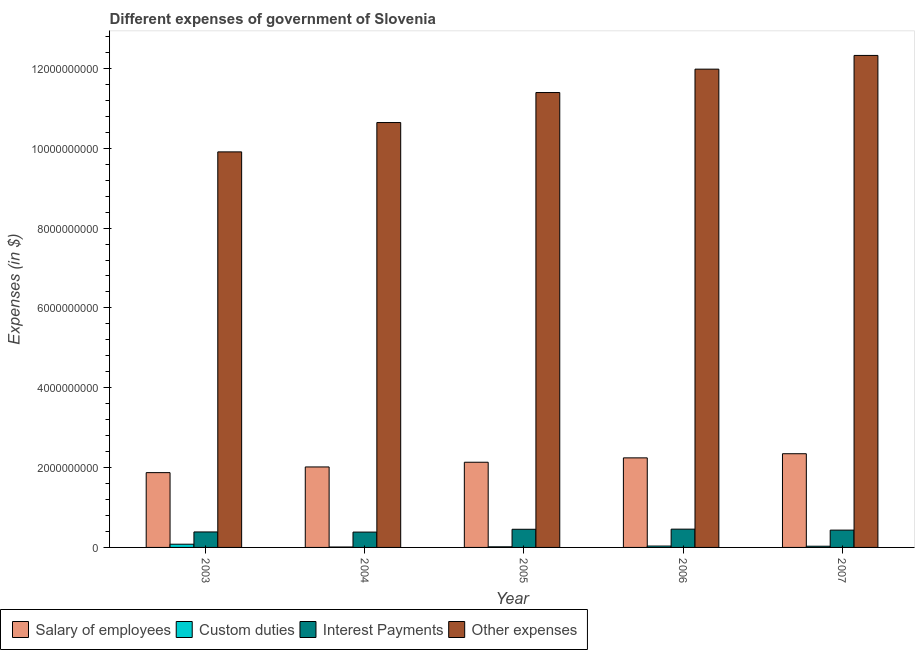How many different coloured bars are there?
Give a very brief answer. 4. Are the number of bars on each tick of the X-axis equal?
Give a very brief answer. Yes. How many bars are there on the 1st tick from the right?
Ensure brevity in your answer.  4. In how many cases, is the number of bars for a given year not equal to the number of legend labels?
Make the answer very short. 0. What is the amount spent on interest payments in 2004?
Your answer should be very brief. 3.84e+08. Across all years, what is the maximum amount spent on other expenses?
Ensure brevity in your answer.  1.23e+1. Across all years, what is the minimum amount spent on custom duties?
Keep it short and to the point. 1.07e+07. In which year was the amount spent on salary of employees maximum?
Give a very brief answer. 2007. What is the total amount spent on other expenses in the graph?
Make the answer very short. 5.63e+1. What is the difference between the amount spent on other expenses in 2004 and that in 2006?
Make the answer very short. -1.34e+09. What is the difference between the amount spent on other expenses in 2003 and the amount spent on custom duties in 2006?
Your answer should be very brief. -2.07e+09. What is the average amount spent on salary of employees per year?
Your answer should be very brief. 2.12e+09. In how many years, is the amount spent on interest payments greater than 2800000000 $?
Offer a very short reply. 0. What is the ratio of the amount spent on other expenses in 2003 to that in 2007?
Your answer should be very brief. 0.8. What is the difference between the highest and the second highest amount spent on custom duties?
Offer a very short reply. 4.62e+07. What is the difference between the highest and the lowest amount spent on salary of employees?
Give a very brief answer. 4.74e+08. In how many years, is the amount spent on custom duties greater than the average amount spent on custom duties taken over all years?
Keep it short and to the point. 2. What does the 4th bar from the left in 2004 represents?
Provide a succinct answer. Other expenses. What does the 2nd bar from the right in 2005 represents?
Your answer should be compact. Interest Payments. Is it the case that in every year, the sum of the amount spent on salary of employees and amount spent on custom duties is greater than the amount spent on interest payments?
Give a very brief answer. Yes. Are all the bars in the graph horizontal?
Your answer should be very brief. No. Are the values on the major ticks of Y-axis written in scientific E-notation?
Your response must be concise. No. Does the graph contain any zero values?
Your answer should be compact. No. Does the graph contain grids?
Provide a short and direct response. No. Where does the legend appear in the graph?
Your answer should be compact. Bottom left. How many legend labels are there?
Provide a short and direct response. 4. How are the legend labels stacked?
Your answer should be very brief. Horizontal. What is the title of the graph?
Keep it short and to the point. Different expenses of government of Slovenia. What is the label or title of the X-axis?
Provide a succinct answer. Year. What is the label or title of the Y-axis?
Your response must be concise. Expenses (in $). What is the Expenses (in $) in Salary of employees in 2003?
Give a very brief answer. 1.87e+09. What is the Expenses (in $) in Custom duties in 2003?
Offer a terse response. 8.07e+07. What is the Expenses (in $) of Interest Payments in 2003?
Your answer should be very brief. 3.88e+08. What is the Expenses (in $) in Other expenses in 2003?
Your answer should be very brief. 9.91e+09. What is the Expenses (in $) of Salary of employees in 2004?
Give a very brief answer. 2.02e+09. What is the Expenses (in $) in Custom duties in 2004?
Your response must be concise. 1.07e+07. What is the Expenses (in $) of Interest Payments in 2004?
Offer a very short reply. 3.84e+08. What is the Expenses (in $) in Other expenses in 2004?
Offer a terse response. 1.06e+1. What is the Expenses (in $) of Salary of employees in 2005?
Ensure brevity in your answer.  2.13e+09. What is the Expenses (in $) of Custom duties in 2005?
Make the answer very short. 1.52e+07. What is the Expenses (in $) of Interest Payments in 2005?
Your response must be concise. 4.55e+08. What is the Expenses (in $) of Other expenses in 2005?
Your answer should be compact. 1.14e+1. What is the Expenses (in $) in Salary of employees in 2006?
Keep it short and to the point. 2.24e+09. What is the Expenses (in $) of Custom duties in 2006?
Ensure brevity in your answer.  3.45e+07. What is the Expenses (in $) of Interest Payments in 2006?
Offer a very short reply. 4.58e+08. What is the Expenses (in $) in Other expenses in 2006?
Make the answer very short. 1.20e+1. What is the Expenses (in $) in Salary of employees in 2007?
Provide a short and direct response. 2.35e+09. What is the Expenses (in $) of Custom duties in 2007?
Make the answer very short. 3.00e+07. What is the Expenses (in $) of Interest Payments in 2007?
Provide a short and direct response. 4.34e+08. What is the Expenses (in $) of Other expenses in 2007?
Ensure brevity in your answer.  1.23e+1. Across all years, what is the maximum Expenses (in $) of Salary of employees?
Offer a very short reply. 2.35e+09. Across all years, what is the maximum Expenses (in $) in Custom duties?
Offer a very short reply. 8.07e+07. Across all years, what is the maximum Expenses (in $) of Interest Payments?
Keep it short and to the point. 4.58e+08. Across all years, what is the maximum Expenses (in $) in Other expenses?
Make the answer very short. 1.23e+1. Across all years, what is the minimum Expenses (in $) of Salary of employees?
Provide a succinct answer. 1.87e+09. Across all years, what is the minimum Expenses (in $) in Custom duties?
Offer a very short reply. 1.07e+07. Across all years, what is the minimum Expenses (in $) of Interest Payments?
Ensure brevity in your answer.  3.84e+08. Across all years, what is the minimum Expenses (in $) of Other expenses?
Offer a very short reply. 9.91e+09. What is the total Expenses (in $) of Salary of employees in the graph?
Make the answer very short. 1.06e+1. What is the total Expenses (in $) in Custom duties in the graph?
Offer a very short reply. 1.71e+08. What is the total Expenses (in $) of Interest Payments in the graph?
Make the answer very short. 2.12e+09. What is the total Expenses (in $) of Other expenses in the graph?
Your answer should be compact. 5.63e+1. What is the difference between the Expenses (in $) in Salary of employees in 2003 and that in 2004?
Provide a succinct answer. -1.42e+08. What is the difference between the Expenses (in $) of Custom duties in 2003 and that in 2004?
Provide a short and direct response. 7.00e+07. What is the difference between the Expenses (in $) of Interest Payments in 2003 and that in 2004?
Your answer should be very brief. 3.56e+06. What is the difference between the Expenses (in $) of Other expenses in 2003 and that in 2004?
Provide a succinct answer. -7.35e+08. What is the difference between the Expenses (in $) of Salary of employees in 2003 and that in 2005?
Make the answer very short. -2.60e+08. What is the difference between the Expenses (in $) of Custom duties in 2003 and that in 2005?
Provide a short and direct response. 6.55e+07. What is the difference between the Expenses (in $) in Interest Payments in 2003 and that in 2005?
Ensure brevity in your answer.  -6.71e+07. What is the difference between the Expenses (in $) of Other expenses in 2003 and that in 2005?
Your answer should be very brief. -1.49e+09. What is the difference between the Expenses (in $) in Salary of employees in 2003 and that in 2006?
Give a very brief answer. -3.70e+08. What is the difference between the Expenses (in $) in Custom duties in 2003 and that in 2006?
Your answer should be compact. 4.62e+07. What is the difference between the Expenses (in $) in Interest Payments in 2003 and that in 2006?
Provide a succinct answer. -7.00e+07. What is the difference between the Expenses (in $) in Other expenses in 2003 and that in 2006?
Ensure brevity in your answer.  -2.07e+09. What is the difference between the Expenses (in $) of Salary of employees in 2003 and that in 2007?
Provide a succinct answer. -4.74e+08. What is the difference between the Expenses (in $) in Custom duties in 2003 and that in 2007?
Your response must be concise. 5.07e+07. What is the difference between the Expenses (in $) of Interest Payments in 2003 and that in 2007?
Your response must be concise. -4.60e+07. What is the difference between the Expenses (in $) of Other expenses in 2003 and that in 2007?
Provide a short and direct response. -2.42e+09. What is the difference between the Expenses (in $) in Salary of employees in 2004 and that in 2005?
Offer a very short reply. -1.18e+08. What is the difference between the Expenses (in $) of Custom duties in 2004 and that in 2005?
Your response must be concise. -4.50e+06. What is the difference between the Expenses (in $) of Interest Payments in 2004 and that in 2005?
Ensure brevity in your answer.  -7.07e+07. What is the difference between the Expenses (in $) in Other expenses in 2004 and that in 2005?
Offer a very short reply. -7.52e+08. What is the difference between the Expenses (in $) in Salary of employees in 2004 and that in 2006?
Your response must be concise. -2.28e+08. What is the difference between the Expenses (in $) of Custom duties in 2004 and that in 2006?
Ensure brevity in your answer.  -2.39e+07. What is the difference between the Expenses (in $) of Interest Payments in 2004 and that in 2006?
Your answer should be very brief. -7.36e+07. What is the difference between the Expenses (in $) of Other expenses in 2004 and that in 2006?
Give a very brief answer. -1.34e+09. What is the difference between the Expenses (in $) of Salary of employees in 2004 and that in 2007?
Keep it short and to the point. -3.31e+08. What is the difference between the Expenses (in $) in Custom duties in 2004 and that in 2007?
Offer a terse response. -1.94e+07. What is the difference between the Expenses (in $) in Interest Payments in 2004 and that in 2007?
Keep it short and to the point. -4.95e+07. What is the difference between the Expenses (in $) in Other expenses in 2004 and that in 2007?
Your answer should be compact. -1.68e+09. What is the difference between the Expenses (in $) in Salary of employees in 2005 and that in 2006?
Your response must be concise. -1.10e+08. What is the difference between the Expenses (in $) of Custom duties in 2005 and that in 2006?
Give a very brief answer. -1.94e+07. What is the difference between the Expenses (in $) of Interest Payments in 2005 and that in 2006?
Provide a short and direct response. -2.91e+06. What is the difference between the Expenses (in $) in Other expenses in 2005 and that in 2006?
Offer a very short reply. -5.86e+08. What is the difference between the Expenses (in $) of Salary of employees in 2005 and that in 2007?
Offer a very short reply. -2.14e+08. What is the difference between the Expenses (in $) in Custom duties in 2005 and that in 2007?
Offer a very short reply. -1.49e+07. What is the difference between the Expenses (in $) of Interest Payments in 2005 and that in 2007?
Keep it short and to the point. 2.12e+07. What is the difference between the Expenses (in $) of Other expenses in 2005 and that in 2007?
Keep it short and to the point. -9.30e+08. What is the difference between the Expenses (in $) in Salary of employees in 2006 and that in 2007?
Offer a terse response. -1.04e+08. What is the difference between the Expenses (in $) of Custom duties in 2006 and that in 2007?
Provide a succinct answer. 4.51e+06. What is the difference between the Expenses (in $) of Interest Payments in 2006 and that in 2007?
Make the answer very short. 2.41e+07. What is the difference between the Expenses (in $) of Other expenses in 2006 and that in 2007?
Provide a succinct answer. -3.44e+08. What is the difference between the Expenses (in $) of Salary of employees in 2003 and the Expenses (in $) of Custom duties in 2004?
Ensure brevity in your answer.  1.86e+09. What is the difference between the Expenses (in $) in Salary of employees in 2003 and the Expenses (in $) in Interest Payments in 2004?
Offer a terse response. 1.49e+09. What is the difference between the Expenses (in $) of Salary of employees in 2003 and the Expenses (in $) of Other expenses in 2004?
Keep it short and to the point. -8.77e+09. What is the difference between the Expenses (in $) in Custom duties in 2003 and the Expenses (in $) in Interest Payments in 2004?
Ensure brevity in your answer.  -3.03e+08. What is the difference between the Expenses (in $) in Custom duties in 2003 and the Expenses (in $) in Other expenses in 2004?
Offer a terse response. -1.06e+1. What is the difference between the Expenses (in $) of Interest Payments in 2003 and the Expenses (in $) of Other expenses in 2004?
Your answer should be very brief. -1.03e+1. What is the difference between the Expenses (in $) in Salary of employees in 2003 and the Expenses (in $) in Custom duties in 2005?
Provide a short and direct response. 1.86e+09. What is the difference between the Expenses (in $) of Salary of employees in 2003 and the Expenses (in $) of Interest Payments in 2005?
Offer a very short reply. 1.42e+09. What is the difference between the Expenses (in $) of Salary of employees in 2003 and the Expenses (in $) of Other expenses in 2005?
Offer a terse response. -9.52e+09. What is the difference between the Expenses (in $) of Custom duties in 2003 and the Expenses (in $) of Interest Payments in 2005?
Provide a succinct answer. -3.74e+08. What is the difference between the Expenses (in $) in Custom duties in 2003 and the Expenses (in $) in Other expenses in 2005?
Your answer should be compact. -1.13e+1. What is the difference between the Expenses (in $) of Interest Payments in 2003 and the Expenses (in $) of Other expenses in 2005?
Keep it short and to the point. -1.10e+1. What is the difference between the Expenses (in $) of Salary of employees in 2003 and the Expenses (in $) of Custom duties in 2006?
Your answer should be very brief. 1.84e+09. What is the difference between the Expenses (in $) in Salary of employees in 2003 and the Expenses (in $) in Interest Payments in 2006?
Your answer should be compact. 1.42e+09. What is the difference between the Expenses (in $) of Salary of employees in 2003 and the Expenses (in $) of Other expenses in 2006?
Your response must be concise. -1.01e+1. What is the difference between the Expenses (in $) in Custom duties in 2003 and the Expenses (in $) in Interest Payments in 2006?
Give a very brief answer. -3.77e+08. What is the difference between the Expenses (in $) of Custom duties in 2003 and the Expenses (in $) of Other expenses in 2006?
Ensure brevity in your answer.  -1.19e+1. What is the difference between the Expenses (in $) of Interest Payments in 2003 and the Expenses (in $) of Other expenses in 2006?
Make the answer very short. -1.16e+1. What is the difference between the Expenses (in $) of Salary of employees in 2003 and the Expenses (in $) of Custom duties in 2007?
Ensure brevity in your answer.  1.84e+09. What is the difference between the Expenses (in $) of Salary of employees in 2003 and the Expenses (in $) of Interest Payments in 2007?
Your response must be concise. 1.44e+09. What is the difference between the Expenses (in $) in Salary of employees in 2003 and the Expenses (in $) in Other expenses in 2007?
Your answer should be compact. -1.05e+1. What is the difference between the Expenses (in $) in Custom duties in 2003 and the Expenses (in $) in Interest Payments in 2007?
Provide a succinct answer. -3.53e+08. What is the difference between the Expenses (in $) in Custom duties in 2003 and the Expenses (in $) in Other expenses in 2007?
Ensure brevity in your answer.  -1.22e+1. What is the difference between the Expenses (in $) of Interest Payments in 2003 and the Expenses (in $) of Other expenses in 2007?
Offer a very short reply. -1.19e+1. What is the difference between the Expenses (in $) of Salary of employees in 2004 and the Expenses (in $) of Custom duties in 2005?
Provide a succinct answer. 2.00e+09. What is the difference between the Expenses (in $) in Salary of employees in 2004 and the Expenses (in $) in Interest Payments in 2005?
Provide a short and direct response. 1.56e+09. What is the difference between the Expenses (in $) in Salary of employees in 2004 and the Expenses (in $) in Other expenses in 2005?
Ensure brevity in your answer.  -9.38e+09. What is the difference between the Expenses (in $) in Custom duties in 2004 and the Expenses (in $) in Interest Payments in 2005?
Ensure brevity in your answer.  -4.44e+08. What is the difference between the Expenses (in $) in Custom duties in 2004 and the Expenses (in $) in Other expenses in 2005?
Offer a very short reply. -1.14e+1. What is the difference between the Expenses (in $) of Interest Payments in 2004 and the Expenses (in $) of Other expenses in 2005?
Your answer should be compact. -1.10e+1. What is the difference between the Expenses (in $) of Salary of employees in 2004 and the Expenses (in $) of Custom duties in 2006?
Keep it short and to the point. 1.98e+09. What is the difference between the Expenses (in $) in Salary of employees in 2004 and the Expenses (in $) in Interest Payments in 2006?
Your answer should be compact. 1.56e+09. What is the difference between the Expenses (in $) in Salary of employees in 2004 and the Expenses (in $) in Other expenses in 2006?
Provide a short and direct response. -9.97e+09. What is the difference between the Expenses (in $) in Custom duties in 2004 and the Expenses (in $) in Interest Payments in 2006?
Your response must be concise. -4.47e+08. What is the difference between the Expenses (in $) of Custom duties in 2004 and the Expenses (in $) of Other expenses in 2006?
Keep it short and to the point. -1.20e+1. What is the difference between the Expenses (in $) in Interest Payments in 2004 and the Expenses (in $) in Other expenses in 2006?
Keep it short and to the point. -1.16e+1. What is the difference between the Expenses (in $) in Salary of employees in 2004 and the Expenses (in $) in Custom duties in 2007?
Offer a very short reply. 1.99e+09. What is the difference between the Expenses (in $) in Salary of employees in 2004 and the Expenses (in $) in Interest Payments in 2007?
Your answer should be compact. 1.58e+09. What is the difference between the Expenses (in $) of Salary of employees in 2004 and the Expenses (in $) of Other expenses in 2007?
Your answer should be very brief. -1.03e+1. What is the difference between the Expenses (in $) in Custom duties in 2004 and the Expenses (in $) in Interest Payments in 2007?
Offer a very short reply. -4.23e+08. What is the difference between the Expenses (in $) in Custom duties in 2004 and the Expenses (in $) in Other expenses in 2007?
Provide a short and direct response. -1.23e+1. What is the difference between the Expenses (in $) in Interest Payments in 2004 and the Expenses (in $) in Other expenses in 2007?
Offer a very short reply. -1.19e+1. What is the difference between the Expenses (in $) of Salary of employees in 2005 and the Expenses (in $) of Custom duties in 2006?
Offer a very short reply. 2.10e+09. What is the difference between the Expenses (in $) of Salary of employees in 2005 and the Expenses (in $) of Interest Payments in 2006?
Keep it short and to the point. 1.68e+09. What is the difference between the Expenses (in $) in Salary of employees in 2005 and the Expenses (in $) in Other expenses in 2006?
Your response must be concise. -9.85e+09. What is the difference between the Expenses (in $) in Custom duties in 2005 and the Expenses (in $) in Interest Payments in 2006?
Provide a short and direct response. -4.43e+08. What is the difference between the Expenses (in $) in Custom duties in 2005 and the Expenses (in $) in Other expenses in 2006?
Provide a short and direct response. -1.20e+1. What is the difference between the Expenses (in $) of Interest Payments in 2005 and the Expenses (in $) of Other expenses in 2006?
Ensure brevity in your answer.  -1.15e+1. What is the difference between the Expenses (in $) in Salary of employees in 2005 and the Expenses (in $) in Custom duties in 2007?
Your answer should be very brief. 2.10e+09. What is the difference between the Expenses (in $) in Salary of employees in 2005 and the Expenses (in $) in Interest Payments in 2007?
Your response must be concise. 1.70e+09. What is the difference between the Expenses (in $) in Salary of employees in 2005 and the Expenses (in $) in Other expenses in 2007?
Give a very brief answer. -1.02e+1. What is the difference between the Expenses (in $) of Custom duties in 2005 and the Expenses (in $) of Interest Payments in 2007?
Your answer should be compact. -4.18e+08. What is the difference between the Expenses (in $) of Custom duties in 2005 and the Expenses (in $) of Other expenses in 2007?
Make the answer very short. -1.23e+1. What is the difference between the Expenses (in $) of Interest Payments in 2005 and the Expenses (in $) of Other expenses in 2007?
Ensure brevity in your answer.  -1.19e+1. What is the difference between the Expenses (in $) in Salary of employees in 2006 and the Expenses (in $) in Custom duties in 2007?
Provide a short and direct response. 2.21e+09. What is the difference between the Expenses (in $) in Salary of employees in 2006 and the Expenses (in $) in Interest Payments in 2007?
Give a very brief answer. 1.81e+09. What is the difference between the Expenses (in $) of Salary of employees in 2006 and the Expenses (in $) of Other expenses in 2007?
Make the answer very short. -1.01e+1. What is the difference between the Expenses (in $) in Custom duties in 2006 and the Expenses (in $) in Interest Payments in 2007?
Your answer should be compact. -3.99e+08. What is the difference between the Expenses (in $) in Custom duties in 2006 and the Expenses (in $) in Other expenses in 2007?
Keep it short and to the point. -1.23e+1. What is the difference between the Expenses (in $) in Interest Payments in 2006 and the Expenses (in $) in Other expenses in 2007?
Provide a short and direct response. -1.19e+1. What is the average Expenses (in $) of Salary of employees per year?
Provide a succinct answer. 2.12e+09. What is the average Expenses (in $) of Custom duties per year?
Keep it short and to the point. 3.42e+07. What is the average Expenses (in $) of Interest Payments per year?
Offer a terse response. 4.24e+08. What is the average Expenses (in $) of Other expenses per year?
Provide a succinct answer. 1.13e+1. In the year 2003, what is the difference between the Expenses (in $) of Salary of employees and Expenses (in $) of Custom duties?
Your response must be concise. 1.79e+09. In the year 2003, what is the difference between the Expenses (in $) of Salary of employees and Expenses (in $) of Interest Payments?
Keep it short and to the point. 1.49e+09. In the year 2003, what is the difference between the Expenses (in $) in Salary of employees and Expenses (in $) in Other expenses?
Your response must be concise. -8.04e+09. In the year 2003, what is the difference between the Expenses (in $) in Custom duties and Expenses (in $) in Interest Payments?
Your response must be concise. -3.07e+08. In the year 2003, what is the difference between the Expenses (in $) in Custom duties and Expenses (in $) in Other expenses?
Give a very brief answer. -9.83e+09. In the year 2003, what is the difference between the Expenses (in $) of Interest Payments and Expenses (in $) of Other expenses?
Provide a succinct answer. -9.52e+09. In the year 2004, what is the difference between the Expenses (in $) in Salary of employees and Expenses (in $) in Custom duties?
Provide a short and direct response. 2.01e+09. In the year 2004, what is the difference between the Expenses (in $) in Salary of employees and Expenses (in $) in Interest Payments?
Your answer should be very brief. 1.63e+09. In the year 2004, what is the difference between the Expenses (in $) in Salary of employees and Expenses (in $) in Other expenses?
Offer a terse response. -8.63e+09. In the year 2004, what is the difference between the Expenses (in $) in Custom duties and Expenses (in $) in Interest Payments?
Your answer should be compact. -3.73e+08. In the year 2004, what is the difference between the Expenses (in $) in Custom duties and Expenses (in $) in Other expenses?
Make the answer very short. -1.06e+1. In the year 2004, what is the difference between the Expenses (in $) in Interest Payments and Expenses (in $) in Other expenses?
Your answer should be very brief. -1.03e+1. In the year 2005, what is the difference between the Expenses (in $) of Salary of employees and Expenses (in $) of Custom duties?
Offer a terse response. 2.12e+09. In the year 2005, what is the difference between the Expenses (in $) of Salary of employees and Expenses (in $) of Interest Payments?
Make the answer very short. 1.68e+09. In the year 2005, what is the difference between the Expenses (in $) in Salary of employees and Expenses (in $) in Other expenses?
Your response must be concise. -9.26e+09. In the year 2005, what is the difference between the Expenses (in $) of Custom duties and Expenses (in $) of Interest Payments?
Keep it short and to the point. -4.40e+08. In the year 2005, what is the difference between the Expenses (in $) of Custom duties and Expenses (in $) of Other expenses?
Your response must be concise. -1.14e+1. In the year 2005, what is the difference between the Expenses (in $) of Interest Payments and Expenses (in $) of Other expenses?
Offer a terse response. -1.09e+1. In the year 2006, what is the difference between the Expenses (in $) of Salary of employees and Expenses (in $) of Custom duties?
Your answer should be compact. 2.21e+09. In the year 2006, what is the difference between the Expenses (in $) in Salary of employees and Expenses (in $) in Interest Payments?
Provide a short and direct response. 1.79e+09. In the year 2006, what is the difference between the Expenses (in $) of Salary of employees and Expenses (in $) of Other expenses?
Give a very brief answer. -9.74e+09. In the year 2006, what is the difference between the Expenses (in $) of Custom duties and Expenses (in $) of Interest Payments?
Provide a short and direct response. -4.23e+08. In the year 2006, what is the difference between the Expenses (in $) in Custom duties and Expenses (in $) in Other expenses?
Provide a succinct answer. -1.19e+1. In the year 2006, what is the difference between the Expenses (in $) in Interest Payments and Expenses (in $) in Other expenses?
Offer a terse response. -1.15e+1. In the year 2007, what is the difference between the Expenses (in $) of Salary of employees and Expenses (in $) of Custom duties?
Provide a succinct answer. 2.32e+09. In the year 2007, what is the difference between the Expenses (in $) of Salary of employees and Expenses (in $) of Interest Payments?
Give a very brief answer. 1.91e+09. In the year 2007, what is the difference between the Expenses (in $) in Salary of employees and Expenses (in $) in Other expenses?
Offer a terse response. -9.98e+09. In the year 2007, what is the difference between the Expenses (in $) of Custom duties and Expenses (in $) of Interest Payments?
Keep it short and to the point. -4.04e+08. In the year 2007, what is the difference between the Expenses (in $) of Custom duties and Expenses (in $) of Other expenses?
Provide a short and direct response. -1.23e+1. In the year 2007, what is the difference between the Expenses (in $) of Interest Payments and Expenses (in $) of Other expenses?
Offer a very short reply. -1.19e+1. What is the ratio of the Expenses (in $) in Salary of employees in 2003 to that in 2004?
Your answer should be compact. 0.93. What is the ratio of the Expenses (in $) in Custom duties in 2003 to that in 2004?
Ensure brevity in your answer.  7.57. What is the ratio of the Expenses (in $) of Interest Payments in 2003 to that in 2004?
Your answer should be very brief. 1.01. What is the ratio of the Expenses (in $) of Other expenses in 2003 to that in 2004?
Your answer should be very brief. 0.93. What is the ratio of the Expenses (in $) of Salary of employees in 2003 to that in 2005?
Offer a terse response. 0.88. What is the ratio of the Expenses (in $) in Custom duties in 2003 to that in 2005?
Provide a short and direct response. 5.32. What is the ratio of the Expenses (in $) in Interest Payments in 2003 to that in 2005?
Give a very brief answer. 0.85. What is the ratio of the Expenses (in $) of Other expenses in 2003 to that in 2005?
Offer a terse response. 0.87. What is the ratio of the Expenses (in $) in Salary of employees in 2003 to that in 2006?
Offer a very short reply. 0.84. What is the ratio of the Expenses (in $) of Custom duties in 2003 to that in 2006?
Give a very brief answer. 2.34. What is the ratio of the Expenses (in $) of Interest Payments in 2003 to that in 2006?
Provide a succinct answer. 0.85. What is the ratio of the Expenses (in $) in Other expenses in 2003 to that in 2006?
Offer a terse response. 0.83. What is the ratio of the Expenses (in $) of Salary of employees in 2003 to that in 2007?
Give a very brief answer. 0.8. What is the ratio of the Expenses (in $) in Custom duties in 2003 to that in 2007?
Your answer should be very brief. 2.69. What is the ratio of the Expenses (in $) in Interest Payments in 2003 to that in 2007?
Your answer should be very brief. 0.89. What is the ratio of the Expenses (in $) in Other expenses in 2003 to that in 2007?
Provide a short and direct response. 0.8. What is the ratio of the Expenses (in $) in Salary of employees in 2004 to that in 2005?
Offer a very short reply. 0.94. What is the ratio of the Expenses (in $) in Custom duties in 2004 to that in 2005?
Offer a very short reply. 0.7. What is the ratio of the Expenses (in $) of Interest Payments in 2004 to that in 2005?
Your response must be concise. 0.84. What is the ratio of the Expenses (in $) in Other expenses in 2004 to that in 2005?
Your answer should be very brief. 0.93. What is the ratio of the Expenses (in $) in Salary of employees in 2004 to that in 2006?
Keep it short and to the point. 0.9. What is the ratio of the Expenses (in $) in Custom duties in 2004 to that in 2006?
Offer a terse response. 0.31. What is the ratio of the Expenses (in $) of Interest Payments in 2004 to that in 2006?
Provide a short and direct response. 0.84. What is the ratio of the Expenses (in $) in Other expenses in 2004 to that in 2006?
Your answer should be compact. 0.89. What is the ratio of the Expenses (in $) in Salary of employees in 2004 to that in 2007?
Offer a very short reply. 0.86. What is the ratio of the Expenses (in $) of Custom duties in 2004 to that in 2007?
Make the answer very short. 0.36. What is the ratio of the Expenses (in $) in Interest Payments in 2004 to that in 2007?
Your answer should be compact. 0.89. What is the ratio of the Expenses (in $) in Other expenses in 2004 to that in 2007?
Your response must be concise. 0.86. What is the ratio of the Expenses (in $) in Salary of employees in 2005 to that in 2006?
Offer a very short reply. 0.95. What is the ratio of the Expenses (in $) in Custom duties in 2005 to that in 2006?
Your response must be concise. 0.44. What is the ratio of the Expenses (in $) in Interest Payments in 2005 to that in 2006?
Offer a very short reply. 0.99. What is the ratio of the Expenses (in $) in Other expenses in 2005 to that in 2006?
Ensure brevity in your answer.  0.95. What is the ratio of the Expenses (in $) of Salary of employees in 2005 to that in 2007?
Your answer should be very brief. 0.91. What is the ratio of the Expenses (in $) in Custom duties in 2005 to that in 2007?
Make the answer very short. 0.51. What is the ratio of the Expenses (in $) in Interest Payments in 2005 to that in 2007?
Offer a very short reply. 1.05. What is the ratio of the Expenses (in $) in Other expenses in 2005 to that in 2007?
Provide a succinct answer. 0.92. What is the ratio of the Expenses (in $) of Salary of employees in 2006 to that in 2007?
Offer a terse response. 0.96. What is the ratio of the Expenses (in $) of Custom duties in 2006 to that in 2007?
Your answer should be compact. 1.15. What is the ratio of the Expenses (in $) in Interest Payments in 2006 to that in 2007?
Your response must be concise. 1.06. What is the ratio of the Expenses (in $) of Other expenses in 2006 to that in 2007?
Provide a succinct answer. 0.97. What is the difference between the highest and the second highest Expenses (in $) of Salary of employees?
Ensure brevity in your answer.  1.04e+08. What is the difference between the highest and the second highest Expenses (in $) in Custom duties?
Offer a terse response. 4.62e+07. What is the difference between the highest and the second highest Expenses (in $) of Interest Payments?
Provide a short and direct response. 2.91e+06. What is the difference between the highest and the second highest Expenses (in $) of Other expenses?
Your response must be concise. 3.44e+08. What is the difference between the highest and the lowest Expenses (in $) of Salary of employees?
Your answer should be very brief. 4.74e+08. What is the difference between the highest and the lowest Expenses (in $) of Custom duties?
Provide a short and direct response. 7.00e+07. What is the difference between the highest and the lowest Expenses (in $) of Interest Payments?
Keep it short and to the point. 7.36e+07. What is the difference between the highest and the lowest Expenses (in $) in Other expenses?
Your answer should be compact. 2.42e+09. 